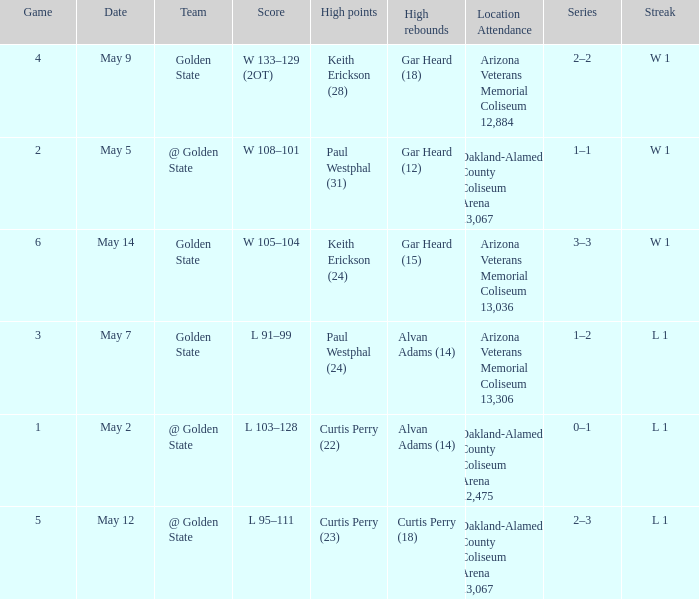How many games had they won or lost in a row on May 9? W 1. 